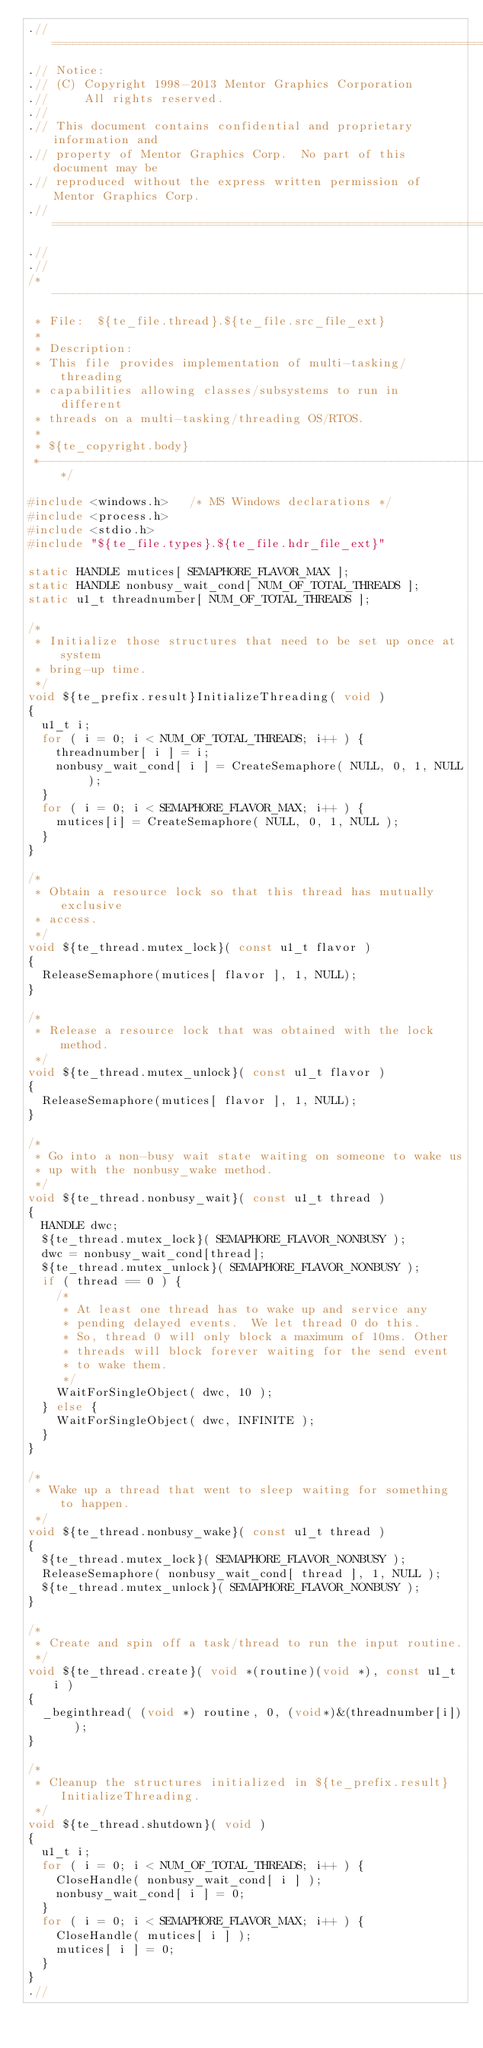<code> <loc_0><loc_0><loc_500><loc_500><_C_>.//============================================================================
.// Notice:
.// (C) Copyright 1998-2013 Mentor Graphics Corporation
.//     All rights reserved.
.//
.// This document contains confidential and proprietary information and
.// property of Mentor Graphics Corp.  No part of this document may be
.// reproduced without the express written permission of Mentor Graphics Corp.
.//============================================================================
.//
.//
/*---------------------------------------------------------------------
 * File:  ${te_file.thread}.${te_file.src_file_ext}
 *
 * Description:
 * This file provides implementation of multi-tasking/threading
 * capabilities allowing classes/subsystems to run in different
 * threads on a multi-tasking/threading OS/RTOS.
 *
 * ${te_copyright.body}
 *-------------------------------------------------------------------*/

#include <windows.h>   /* MS Windows declarations */
#include <process.h>
#include <stdio.h>
#include "${te_file.types}.${te_file.hdr_file_ext}"

static HANDLE mutices[ SEMAPHORE_FLAVOR_MAX ];
static HANDLE nonbusy_wait_cond[ NUM_OF_TOTAL_THREADS ];
static u1_t threadnumber[ NUM_OF_TOTAL_THREADS ];

/*
 * Initialize those structures that need to be set up once at system
 * bring-up time.
 */
void ${te_prefix.result}InitializeThreading( void )
{
  u1_t i;
  for ( i = 0; i < NUM_OF_TOTAL_THREADS; i++ ) {
    threadnumber[ i ] = i;
    nonbusy_wait_cond[ i ] = CreateSemaphore( NULL, 0, 1, NULL );
  }
  for ( i = 0; i < SEMAPHORE_FLAVOR_MAX; i++ ) {
    mutices[i] = CreateSemaphore( NULL, 0, 1, NULL );
  }
}

/*
 * Obtain a resource lock so that this thread has mutually exclusive
 * access.
 */
void ${te_thread.mutex_lock}( const u1_t flavor )
{
  ReleaseSemaphore(mutices[ flavor ], 1, NULL);
}

/*
 * Release a resource lock that was obtained with the lock method.
 */
void ${te_thread.mutex_unlock}( const u1_t flavor )
{
  ReleaseSemaphore(mutices[ flavor ], 1, NULL);
}

/*
 * Go into a non-busy wait state waiting on someone to wake us
 * up with the nonbusy_wake method.
 */
void ${te_thread.nonbusy_wait}( const u1_t thread )
{
  HANDLE dwc;
  ${te_thread.mutex_lock}( SEMAPHORE_FLAVOR_NONBUSY );
  dwc = nonbusy_wait_cond[thread];
  ${te_thread.mutex_unlock}( SEMAPHORE_FLAVOR_NONBUSY );
  if ( thread == 0 ) {
    /*
     * At least one thread has to wake up and service any
     * pending delayed events.  We let thread 0 do this.
     * So, thread 0 will only block a maximum of 10ms. Other 
     * threads will block forever waiting for the send event 
     * to wake them.
     */
    WaitForSingleObject( dwc, 10 );
  } else {
    WaitForSingleObject( dwc, INFINITE );
  }
}

/*
 * Wake up a thread that went to sleep waiting for something to happen.
 */
void ${te_thread.nonbusy_wake}( const u1_t thread )
{
  ${te_thread.mutex_lock}( SEMAPHORE_FLAVOR_NONBUSY );
  ReleaseSemaphore( nonbusy_wait_cond[ thread ], 1, NULL );
  ${te_thread.mutex_unlock}( SEMAPHORE_FLAVOR_NONBUSY );
}

/*
 * Create and spin off a task/thread to run the input routine.
 */
void ${te_thread.create}( void *(routine)(void *), const u1_t i )
{
  _beginthread( (void *) routine, 0, (void*)&(threadnumber[i]) );
}

/*
 * Cleanup the structures initialized in ${te_prefix.result}InitializeThreading.
 */
void ${te_thread.shutdown}( void )
{
  u1_t i;
  for ( i = 0; i < NUM_OF_TOTAL_THREADS; i++ ) {
    CloseHandle( nonbusy_wait_cond[ i ] );
    nonbusy_wait_cond[ i ] = 0;
  }
  for ( i = 0; i < SEMAPHORE_FLAVOR_MAX; i++ ) {
    CloseHandle( mutices[ i ] );
    mutices[ i ] = 0;
  }
}
.//
</code> 